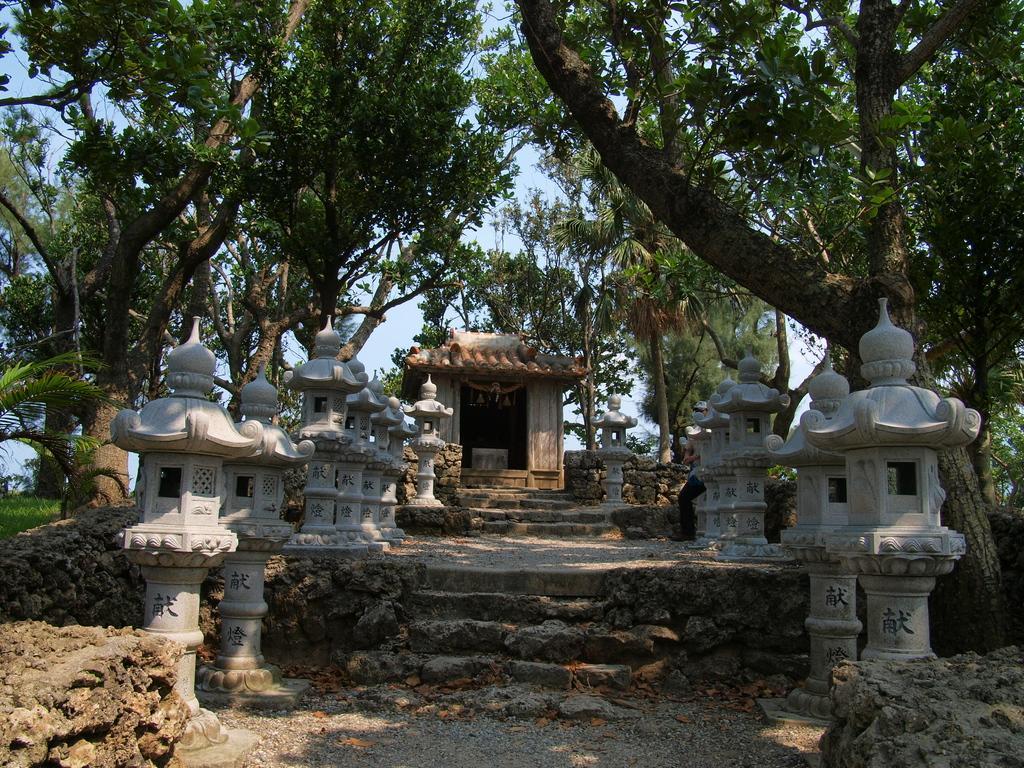Describe this image in one or two sentences. In this image, we can see a house. We can see some stairs and a few pillars with sculptures. We can see the ground. We can also see some grass, plants and trees. We can also see the sky. 